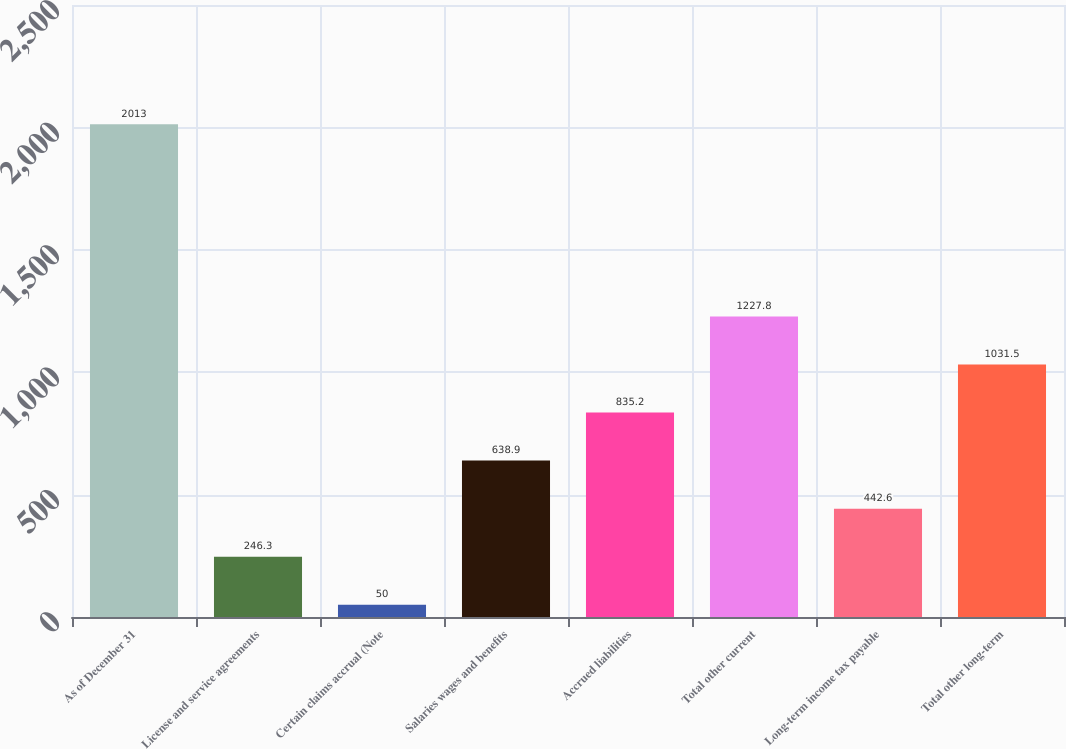Convert chart. <chart><loc_0><loc_0><loc_500><loc_500><bar_chart><fcel>As of December 31<fcel>License and service agreements<fcel>Certain claims accrual (Note<fcel>Salaries wages and benefits<fcel>Accrued liabilities<fcel>Total other current<fcel>Long-term income tax payable<fcel>Total other long-term<nl><fcel>2013<fcel>246.3<fcel>50<fcel>638.9<fcel>835.2<fcel>1227.8<fcel>442.6<fcel>1031.5<nl></chart> 